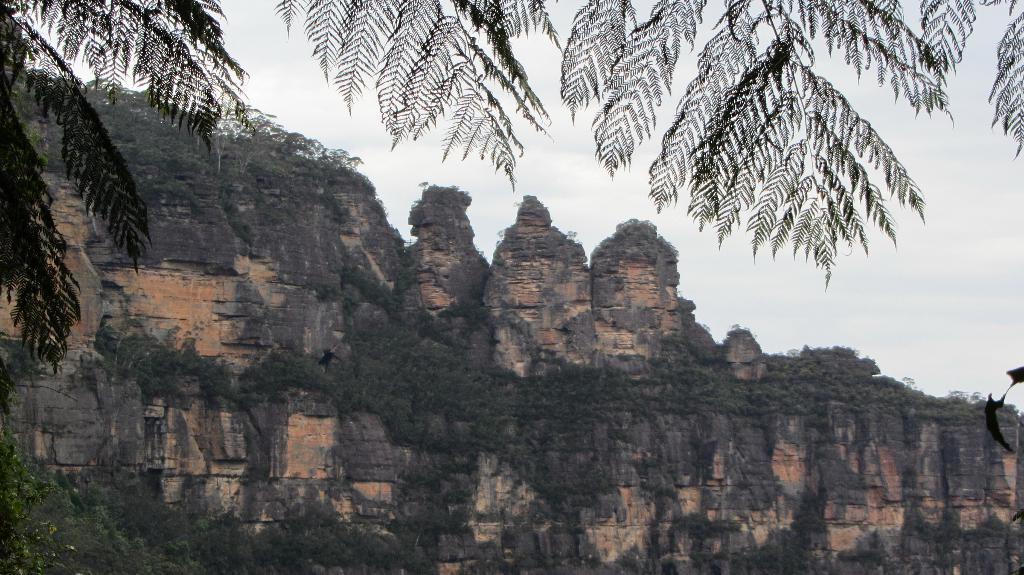What type of vegetation is present in the front of the image? There are trees in the front of the image. What type of geographical feature can be seen in the background of the image? There are rocky mountains in the background of the image. What part of the natural environment is visible in the background of the image? The sky is visible in the background of the image. How many stores can be seen in the image? There are no stores present in the image. What type of flight is visible in the image? There is no flight visible in the image. 